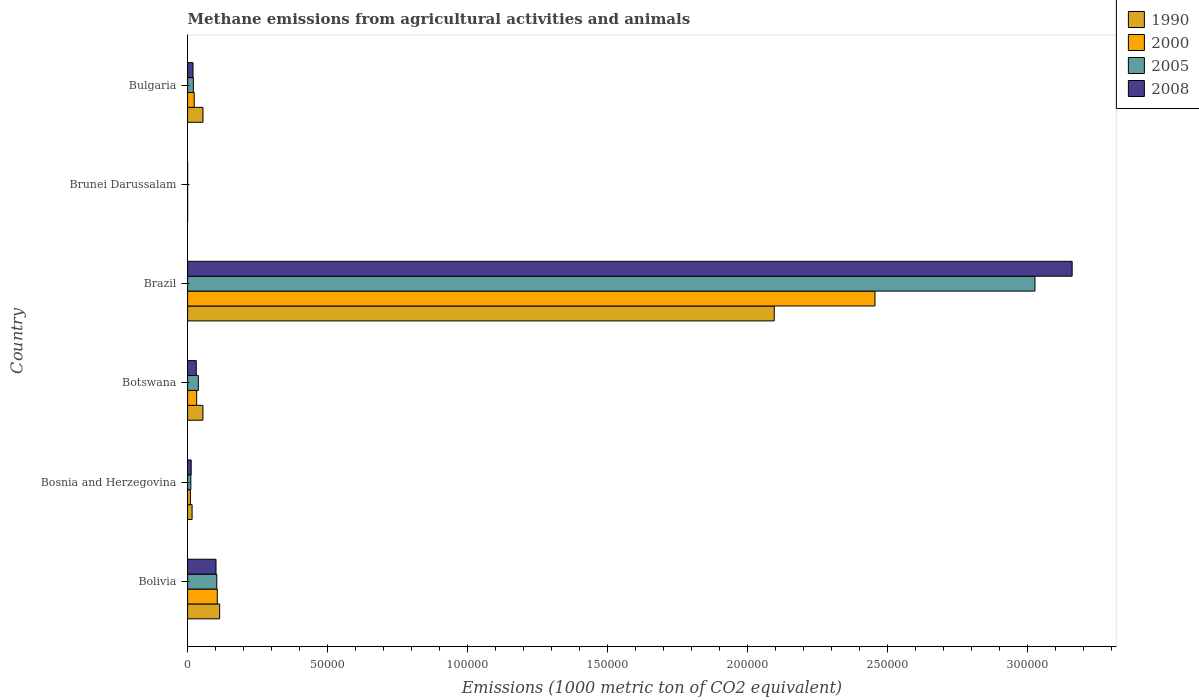How many groups of bars are there?
Your response must be concise. 6. How many bars are there on the 1st tick from the bottom?
Your response must be concise. 4. What is the amount of methane emitted in 2000 in Botswana?
Make the answer very short. 3234. Across all countries, what is the maximum amount of methane emitted in 1990?
Provide a succinct answer. 2.10e+05. In which country was the amount of methane emitted in 2000 minimum?
Your answer should be very brief. Brunei Darussalam. What is the total amount of methane emitted in 2008 in the graph?
Make the answer very short. 3.32e+05. What is the difference between the amount of methane emitted in 2008 in Botswana and that in Brazil?
Provide a short and direct response. -3.13e+05. What is the difference between the amount of methane emitted in 2008 in Botswana and the amount of methane emitted in 2000 in Brunei Darussalam?
Give a very brief answer. 3081.1. What is the average amount of methane emitted in 2005 per country?
Your response must be concise. 5.34e+04. What is the difference between the amount of methane emitted in 1990 and amount of methane emitted in 2005 in Brazil?
Provide a succinct answer. -9.31e+04. What is the ratio of the amount of methane emitted in 2008 in Botswana to that in Brunei Darussalam?
Provide a succinct answer. 216.53. Is the amount of methane emitted in 2008 in Brazil less than that in Brunei Darussalam?
Keep it short and to the point. No. What is the difference between the highest and the second highest amount of methane emitted in 1990?
Offer a very short reply. 1.98e+05. What is the difference between the highest and the lowest amount of methane emitted in 1990?
Provide a succinct answer. 2.10e+05. What does the 2nd bar from the top in Brunei Darussalam represents?
Keep it short and to the point. 2005. What is the difference between two consecutive major ticks on the X-axis?
Provide a succinct answer. 5.00e+04. Does the graph contain grids?
Offer a terse response. No. Where does the legend appear in the graph?
Your answer should be very brief. Top right. What is the title of the graph?
Provide a short and direct response. Methane emissions from agricultural activities and animals. What is the label or title of the X-axis?
Keep it short and to the point. Emissions (1000 metric ton of CO2 equivalent). What is the Emissions (1000 metric ton of CO2 equivalent) of 1990 in Bolivia?
Keep it short and to the point. 1.14e+04. What is the Emissions (1000 metric ton of CO2 equivalent) of 2000 in Bolivia?
Provide a short and direct response. 1.06e+04. What is the Emissions (1000 metric ton of CO2 equivalent) of 2005 in Bolivia?
Ensure brevity in your answer.  1.04e+04. What is the Emissions (1000 metric ton of CO2 equivalent) in 2008 in Bolivia?
Offer a terse response. 1.01e+04. What is the Emissions (1000 metric ton of CO2 equivalent) of 1990 in Bosnia and Herzegovina?
Offer a terse response. 1604.3. What is the Emissions (1000 metric ton of CO2 equivalent) in 2000 in Bosnia and Herzegovina?
Your response must be concise. 996.6. What is the Emissions (1000 metric ton of CO2 equivalent) in 2005 in Bosnia and Herzegovina?
Provide a succinct answer. 1161.2. What is the Emissions (1000 metric ton of CO2 equivalent) of 2008 in Bosnia and Herzegovina?
Make the answer very short. 1279.4. What is the Emissions (1000 metric ton of CO2 equivalent) of 1990 in Botswana?
Your response must be concise. 5471.2. What is the Emissions (1000 metric ton of CO2 equivalent) in 2000 in Botswana?
Your response must be concise. 3234. What is the Emissions (1000 metric ton of CO2 equivalent) in 2005 in Botswana?
Give a very brief answer. 3850.6. What is the Emissions (1000 metric ton of CO2 equivalent) of 2008 in Botswana?
Provide a succinct answer. 3096.4. What is the Emissions (1000 metric ton of CO2 equivalent) of 1990 in Brazil?
Give a very brief answer. 2.10e+05. What is the Emissions (1000 metric ton of CO2 equivalent) in 2000 in Brazil?
Give a very brief answer. 2.45e+05. What is the Emissions (1000 metric ton of CO2 equivalent) in 2005 in Brazil?
Offer a terse response. 3.03e+05. What is the Emissions (1000 metric ton of CO2 equivalent) of 2008 in Brazil?
Offer a very short reply. 3.16e+05. What is the Emissions (1000 metric ton of CO2 equivalent) in 2005 in Brunei Darussalam?
Give a very brief answer. 14.1. What is the Emissions (1000 metric ton of CO2 equivalent) in 1990 in Bulgaria?
Provide a succinct answer. 5498.3. What is the Emissions (1000 metric ton of CO2 equivalent) of 2000 in Bulgaria?
Offer a terse response. 2359.5. What is the Emissions (1000 metric ton of CO2 equivalent) in 2005 in Bulgaria?
Your answer should be compact. 2055.2. What is the Emissions (1000 metric ton of CO2 equivalent) of 2008 in Bulgaria?
Keep it short and to the point. 1942.2. Across all countries, what is the maximum Emissions (1000 metric ton of CO2 equivalent) of 1990?
Your answer should be very brief. 2.10e+05. Across all countries, what is the maximum Emissions (1000 metric ton of CO2 equivalent) in 2000?
Ensure brevity in your answer.  2.45e+05. Across all countries, what is the maximum Emissions (1000 metric ton of CO2 equivalent) in 2005?
Your answer should be compact. 3.03e+05. Across all countries, what is the maximum Emissions (1000 metric ton of CO2 equivalent) in 2008?
Ensure brevity in your answer.  3.16e+05. Across all countries, what is the minimum Emissions (1000 metric ton of CO2 equivalent) of 1990?
Keep it short and to the point. 12.5. Across all countries, what is the minimum Emissions (1000 metric ton of CO2 equivalent) in 2000?
Your answer should be very brief. 15.3. Across all countries, what is the minimum Emissions (1000 metric ton of CO2 equivalent) of 2008?
Your answer should be compact. 14.3. What is the total Emissions (1000 metric ton of CO2 equivalent) of 1990 in the graph?
Ensure brevity in your answer.  2.34e+05. What is the total Emissions (1000 metric ton of CO2 equivalent) in 2000 in the graph?
Give a very brief answer. 2.63e+05. What is the total Emissions (1000 metric ton of CO2 equivalent) of 2005 in the graph?
Make the answer very short. 3.20e+05. What is the total Emissions (1000 metric ton of CO2 equivalent) of 2008 in the graph?
Make the answer very short. 3.32e+05. What is the difference between the Emissions (1000 metric ton of CO2 equivalent) in 1990 in Bolivia and that in Bosnia and Herzegovina?
Offer a terse response. 9840.7. What is the difference between the Emissions (1000 metric ton of CO2 equivalent) in 2000 in Bolivia and that in Bosnia and Herzegovina?
Offer a very short reply. 9613.1. What is the difference between the Emissions (1000 metric ton of CO2 equivalent) in 2005 in Bolivia and that in Bosnia and Herzegovina?
Keep it short and to the point. 9254.6. What is the difference between the Emissions (1000 metric ton of CO2 equivalent) in 2008 in Bolivia and that in Bosnia and Herzegovina?
Provide a succinct answer. 8868.1. What is the difference between the Emissions (1000 metric ton of CO2 equivalent) of 1990 in Bolivia and that in Botswana?
Give a very brief answer. 5973.8. What is the difference between the Emissions (1000 metric ton of CO2 equivalent) of 2000 in Bolivia and that in Botswana?
Your answer should be compact. 7375.7. What is the difference between the Emissions (1000 metric ton of CO2 equivalent) in 2005 in Bolivia and that in Botswana?
Your answer should be compact. 6565.2. What is the difference between the Emissions (1000 metric ton of CO2 equivalent) in 2008 in Bolivia and that in Botswana?
Provide a succinct answer. 7051.1. What is the difference between the Emissions (1000 metric ton of CO2 equivalent) of 1990 in Bolivia and that in Brazil?
Keep it short and to the point. -1.98e+05. What is the difference between the Emissions (1000 metric ton of CO2 equivalent) of 2000 in Bolivia and that in Brazil?
Your response must be concise. -2.35e+05. What is the difference between the Emissions (1000 metric ton of CO2 equivalent) in 2005 in Bolivia and that in Brazil?
Offer a terse response. -2.92e+05. What is the difference between the Emissions (1000 metric ton of CO2 equivalent) in 2008 in Bolivia and that in Brazil?
Your response must be concise. -3.06e+05. What is the difference between the Emissions (1000 metric ton of CO2 equivalent) in 1990 in Bolivia and that in Brunei Darussalam?
Offer a very short reply. 1.14e+04. What is the difference between the Emissions (1000 metric ton of CO2 equivalent) of 2000 in Bolivia and that in Brunei Darussalam?
Ensure brevity in your answer.  1.06e+04. What is the difference between the Emissions (1000 metric ton of CO2 equivalent) in 2005 in Bolivia and that in Brunei Darussalam?
Offer a terse response. 1.04e+04. What is the difference between the Emissions (1000 metric ton of CO2 equivalent) in 2008 in Bolivia and that in Brunei Darussalam?
Keep it short and to the point. 1.01e+04. What is the difference between the Emissions (1000 metric ton of CO2 equivalent) of 1990 in Bolivia and that in Bulgaria?
Your answer should be compact. 5946.7. What is the difference between the Emissions (1000 metric ton of CO2 equivalent) of 2000 in Bolivia and that in Bulgaria?
Keep it short and to the point. 8250.2. What is the difference between the Emissions (1000 metric ton of CO2 equivalent) in 2005 in Bolivia and that in Bulgaria?
Ensure brevity in your answer.  8360.6. What is the difference between the Emissions (1000 metric ton of CO2 equivalent) of 2008 in Bolivia and that in Bulgaria?
Give a very brief answer. 8205.3. What is the difference between the Emissions (1000 metric ton of CO2 equivalent) in 1990 in Bosnia and Herzegovina and that in Botswana?
Offer a very short reply. -3866.9. What is the difference between the Emissions (1000 metric ton of CO2 equivalent) in 2000 in Bosnia and Herzegovina and that in Botswana?
Your answer should be very brief. -2237.4. What is the difference between the Emissions (1000 metric ton of CO2 equivalent) of 2005 in Bosnia and Herzegovina and that in Botswana?
Your answer should be very brief. -2689.4. What is the difference between the Emissions (1000 metric ton of CO2 equivalent) in 2008 in Bosnia and Herzegovina and that in Botswana?
Make the answer very short. -1817. What is the difference between the Emissions (1000 metric ton of CO2 equivalent) in 1990 in Bosnia and Herzegovina and that in Brazil?
Your answer should be compact. -2.08e+05. What is the difference between the Emissions (1000 metric ton of CO2 equivalent) in 2000 in Bosnia and Herzegovina and that in Brazil?
Your answer should be very brief. -2.44e+05. What is the difference between the Emissions (1000 metric ton of CO2 equivalent) in 2005 in Bosnia and Herzegovina and that in Brazil?
Make the answer very short. -3.01e+05. What is the difference between the Emissions (1000 metric ton of CO2 equivalent) in 2008 in Bosnia and Herzegovina and that in Brazil?
Offer a terse response. -3.15e+05. What is the difference between the Emissions (1000 metric ton of CO2 equivalent) in 1990 in Bosnia and Herzegovina and that in Brunei Darussalam?
Keep it short and to the point. 1591.8. What is the difference between the Emissions (1000 metric ton of CO2 equivalent) of 2000 in Bosnia and Herzegovina and that in Brunei Darussalam?
Provide a short and direct response. 981.3. What is the difference between the Emissions (1000 metric ton of CO2 equivalent) of 2005 in Bosnia and Herzegovina and that in Brunei Darussalam?
Ensure brevity in your answer.  1147.1. What is the difference between the Emissions (1000 metric ton of CO2 equivalent) in 2008 in Bosnia and Herzegovina and that in Brunei Darussalam?
Ensure brevity in your answer.  1265.1. What is the difference between the Emissions (1000 metric ton of CO2 equivalent) in 1990 in Bosnia and Herzegovina and that in Bulgaria?
Make the answer very short. -3894. What is the difference between the Emissions (1000 metric ton of CO2 equivalent) in 2000 in Bosnia and Herzegovina and that in Bulgaria?
Provide a short and direct response. -1362.9. What is the difference between the Emissions (1000 metric ton of CO2 equivalent) of 2005 in Bosnia and Herzegovina and that in Bulgaria?
Your answer should be compact. -894. What is the difference between the Emissions (1000 metric ton of CO2 equivalent) of 2008 in Bosnia and Herzegovina and that in Bulgaria?
Your response must be concise. -662.8. What is the difference between the Emissions (1000 metric ton of CO2 equivalent) in 1990 in Botswana and that in Brazil?
Provide a succinct answer. -2.04e+05. What is the difference between the Emissions (1000 metric ton of CO2 equivalent) of 2000 in Botswana and that in Brazil?
Your answer should be very brief. -2.42e+05. What is the difference between the Emissions (1000 metric ton of CO2 equivalent) of 2005 in Botswana and that in Brazil?
Give a very brief answer. -2.99e+05. What is the difference between the Emissions (1000 metric ton of CO2 equivalent) in 2008 in Botswana and that in Brazil?
Keep it short and to the point. -3.13e+05. What is the difference between the Emissions (1000 metric ton of CO2 equivalent) of 1990 in Botswana and that in Brunei Darussalam?
Ensure brevity in your answer.  5458.7. What is the difference between the Emissions (1000 metric ton of CO2 equivalent) of 2000 in Botswana and that in Brunei Darussalam?
Offer a terse response. 3218.7. What is the difference between the Emissions (1000 metric ton of CO2 equivalent) in 2005 in Botswana and that in Brunei Darussalam?
Make the answer very short. 3836.5. What is the difference between the Emissions (1000 metric ton of CO2 equivalent) of 2008 in Botswana and that in Brunei Darussalam?
Your answer should be very brief. 3082.1. What is the difference between the Emissions (1000 metric ton of CO2 equivalent) of 1990 in Botswana and that in Bulgaria?
Your answer should be very brief. -27.1. What is the difference between the Emissions (1000 metric ton of CO2 equivalent) of 2000 in Botswana and that in Bulgaria?
Your answer should be compact. 874.5. What is the difference between the Emissions (1000 metric ton of CO2 equivalent) in 2005 in Botswana and that in Bulgaria?
Make the answer very short. 1795.4. What is the difference between the Emissions (1000 metric ton of CO2 equivalent) in 2008 in Botswana and that in Bulgaria?
Ensure brevity in your answer.  1154.2. What is the difference between the Emissions (1000 metric ton of CO2 equivalent) of 1990 in Brazil and that in Brunei Darussalam?
Offer a very short reply. 2.10e+05. What is the difference between the Emissions (1000 metric ton of CO2 equivalent) in 2000 in Brazil and that in Brunei Darussalam?
Your answer should be compact. 2.45e+05. What is the difference between the Emissions (1000 metric ton of CO2 equivalent) of 2005 in Brazil and that in Brunei Darussalam?
Ensure brevity in your answer.  3.03e+05. What is the difference between the Emissions (1000 metric ton of CO2 equivalent) in 2008 in Brazil and that in Brunei Darussalam?
Your response must be concise. 3.16e+05. What is the difference between the Emissions (1000 metric ton of CO2 equivalent) of 1990 in Brazil and that in Bulgaria?
Provide a short and direct response. 2.04e+05. What is the difference between the Emissions (1000 metric ton of CO2 equivalent) in 2000 in Brazil and that in Bulgaria?
Provide a succinct answer. 2.43e+05. What is the difference between the Emissions (1000 metric ton of CO2 equivalent) in 2005 in Brazil and that in Bulgaria?
Keep it short and to the point. 3.01e+05. What is the difference between the Emissions (1000 metric ton of CO2 equivalent) of 2008 in Brazil and that in Bulgaria?
Your answer should be very brief. 3.14e+05. What is the difference between the Emissions (1000 metric ton of CO2 equivalent) in 1990 in Brunei Darussalam and that in Bulgaria?
Ensure brevity in your answer.  -5485.8. What is the difference between the Emissions (1000 metric ton of CO2 equivalent) of 2000 in Brunei Darussalam and that in Bulgaria?
Give a very brief answer. -2344.2. What is the difference between the Emissions (1000 metric ton of CO2 equivalent) in 2005 in Brunei Darussalam and that in Bulgaria?
Give a very brief answer. -2041.1. What is the difference between the Emissions (1000 metric ton of CO2 equivalent) of 2008 in Brunei Darussalam and that in Bulgaria?
Provide a short and direct response. -1927.9. What is the difference between the Emissions (1000 metric ton of CO2 equivalent) of 1990 in Bolivia and the Emissions (1000 metric ton of CO2 equivalent) of 2000 in Bosnia and Herzegovina?
Keep it short and to the point. 1.04e+04. What is the difference between the Emissions (1000 metric ton of CO2 equivalent) in 1990 in Bolivia and the Emissions (1000 metric ton of CO2 equivalent) in 2005 in Bosnia and Herzegovina?
Offer a very short reply. 1.03e+04. What is the difference between the Emissions (1000 metric ton of CO2 equivalent) of 1990 in Bolivia and the Emissions (1000 metric ton of CO2 equivalent) of 2008 in Bosnia and Herzegovina?
Ensure brevity in your answer.  1.02e+04. What is the difference between the Emissions (1000 metric ton of CO2 equivalent) in 2000 in Bolivia and the Emissions (1000 metric ton of CO2 equivalent) in 2005 in Bosnia and Herzegovina?
Ensure brevity in your answer.  9448.5. What is the difference between the Emissions (1000 metric ton of CO2 equivalent) of 2000 in Bolivia and the Emissions (1000 metric ton of CO2 equivalent) of 2008 in Bosnia and Herzegovina?
Offer a very short reply. 9330.3. What is the difference between the Emissions (1000 metric ton of CO2 equivalent) in 2005 in Bolivia and the Emissions (1000 metric ton of CO2 equivalent) in 2008 in Bosnia and Herzegovina?
Your answer should be compact. 9136.4. What is the difference between the Emissions (1000 metric ton of CO2 equivalent) of 1990 in Bolivia and the Emissions (1000 metric ton of CO2 equivalent) of 2000 in Botswana?
Provide a short and direct response. 8211. What is the difference between the Emissions (1000 metric ton of CO2 equivalent) in 1990 in Bolivia and the Emissions (1000 metric ton of CO2 equivalent) in 2005 in Botswana?
Give a very brief answer. 7594.4. What is the difference between the Emissions (1000 metric ton of CO2 equivalent) of 1990 in Bolivia and the Emissions (1000 metric ton of CO2 equivalent) of 2008 in Botswana?
Provide a succinct answer. 8348.6. What is the difference between the Emissions (1000 metric ton of CO2 equivalent) of 2000 in Bolivia and the Emissions (1000 metric ton of CO2 equivalent) of 2005 in Botswana?
Provide a short and direct response. 6759.1. What is the difference between the Emissions (1000 metric ton of CO2 equivalent) in 2000 in Bolivia and the Emissions (1000 metric ton of CO2 equivalent) in 2008 in Botswana?
Make the answer very short. 7513.3. What is the difference between the Emissions (1000 metric ton of CO2 equivalent) of 2005 in Bolivia and the Emissions (1000 metric ton of CO2 equivalent) of 2008 in Botswana?
Your answer should be very brief. 7319.4. What is the difference between the Emissions (1000 metric ton of CO2 equivalent) of 1990 in Bolivia and the Emissions (1000 metric ton of CO2 equivalent) of 2000 in Brazil?
Your answer should be compact. -2.34e+05. What is the difference between the Emissions (1000 metric ton of CO2 equivalent) in 1990 in Bolivia and the Emissions (1000 metric ton of CO2 equivalent) in 2005 in Brazil?
Offer a very short reply. -2.91e+05. What is the difference between the Emissions (1000 metric ton of CO2 equivalent) in 1990 in Bolivia and the Emissions (1000 metric ton of CO2 equivalent) in 2008 in Brazil?
Your response must be concise. -3.04e+05. What is the difference between the Emissions (1000 metric ton of CO2 equivalent) of 2000 in Bolivia and the Emissions (1000 metric ton of CO2 equivalent) of 2005 in Brazil?
Offer a terse response. -2.92e+05. What is the difference between the Emissions (1000 metric ton of CO2 equivalent) in 2000 in Bolivia and the Emissions (1000 metric ton of CO2 equivalent) in 2008 in Brazil?
Your answer should be compact. -3.05e+05. What is the difference between the Emissions (1000 metric ton of CO2 equivalent) in 2005 in Bolivia and the Emissions (1000 metric ton of CO2 equivalent) in 2008 in Brazil?
Give a very brief answer. -3.05e+05. What is the difference between the Emissions (1000 metric ton of CO2 equivalent) in 1990 in Bolivia and the Emissions (1000 metric ton of CO2 equivalent) in 2000 in Brunei Darussalam?
Give a very brief answer. 1.14e+04. What is the difference between the Emissions (1000 metric ton of CO2 equivalent) in 1990 in Bolivia and the Emissions (1000 metric ton of CO2 equivalent) in 2005 in Brunei Darussalam?
Make the answer very short. 1.14e+04. What is the difference between the Emissions (1000 metric ton of CO2 equivalent) of 1990 in Bolivia and the Emissions (1000 metric ton of CO2 equivalent) of 2008 in Brunei Darussalam?
Your answer should be compact. 1.14e+04. What is the difference between the Emissions (1000 metric ton of CO2 equivalent) of 2000 in Bolivia and the Emissions (1000 metric ton of CO2 equivalent) of 2005 in Brunei Darussalam?
Provide a succinct answer. 1.06e+04. What is the difference between the Emissions (1000 metric ton of CO2 equivalent) in 2000 in Bolivia and the Emissions (1000 metric ton of CO2 equivalent) in 2008 in Brunei Darussalam?
Your answer should be compact. 1.06e+04. What is the difference between the Emissions (1000 metric ton of CO2 equivalent) in 2005 in Bolivia and the Emissions (1000 metric ton of CO2 equivalent) in 2008 in Brunei Darussalam?
Offer a terse response. 1.04e+04. What is the difference between the Emissions (1000 metric ton of CO2 equivalent) of 1990 in Bolivia and the Emissions (1000 metric ton of CO2 equivalent) of 2000 in Bulgaria?
Offer a terse response. 9085.5. What is the difference between the Emissions (1000 metric ton of CO2 equivalent) in 1990 in Bolivia and the Emissions (1000 metric ton of CO2 equivalent) in 2005 in Bulgaria?
Offer a terse response. 9389.8. What is the difference between the Emissions (1000 metric ton of CO2 equivalent) in 1990 in Bolivia and the Emissions (1000 metric ton of CO2 equivalent) in 2008 in Bulgaria?
Keep it short and to the point. 9502.8. What is the difference between the Emissions (1000 metric ton of CO2 equivalent) of 2000 in Bolivia and the Emissions (1000 metric ton of CO2 equivalent) of 2005 in Bulgaria?
Ensure brevity in your answer.  8554.5. What is the difference between the Emissions (1000 metric ton of CO2 equivalent) in 2000 in Bolivia and the Emissions (1000 metric ton of CO2 equivalent) in 2008 in Bulgaria?
Provide a short and direct response. 8667.5. What is the difference between the Emissions (1000 metric ton of CO2 equivalent) in 2005 in Bolivia and the Emissions (1000 metric ton of CO2 equivalent) in 2008 in Bulgaria?
Make the answer very short. 8473.6. What is the difference between the Emissions (1000 metric ton of CO2 equivalent) of 1990 in Bosnia and Herzegovina and the Emissions (1000 metric ton of CO2 equivalent) of 2000 in Botswana?
Provide a succinct answer. -1629.7. What is the difference between the Emissions (1000 metric ton of CO2 equivalent) in 1990 in Bosnia and Herzegovina and the Emissions (1000 metric ton of CO2 equivalent) in 2005 in Botswana?
Make the answer very short. -2246.3. What is the difference between the Emissions (1000 metric ton of CO2 equivalent) of 1990 in Bosnia and Herzegovina and the Emissions (1000 metric ton of CO2 equivalent) of 2008 in Botswana?
Your response must be concise. -1492.1. What is the difference between the Emissions (1000 metric ton of CO2 equivalent) of 2000 in Bosnia and Herzegovina and the Emissions (1000 metric ton of CO2 equivalent) of 2005 in Botswana?
Offer a very short reply. -2854. What is the difference between the Emissions (1000 metric ton of CO2 equivalent) in 2000 in Bosnia and Herzegovina and the Emissions (1000 metric ton of CO2 equivalent) in 2008 in Botswana?
Your answer should be very brief. -2099.8. What is the difference between the Emissions (1000 metric ton of CO2 equivalent) in 2005 in Bosnia and Herzegovina and the Emissions (1000 metric ton of CO2 equivalent) in 2008 in Botswana?
Your response must be concise. -1935.2. What is the difference between the Emissions (1000 metric ton of CO2 equivalent) of 1990 in Bosnia and Herzegovina and the Emissions (1000 metric ton of CO2 equivalent) of 2000 in Brazil?
Ensure brevity in your answer.  -2.44e+05. What is the difference between the Emissions (1000 metric ton of CO2 equivalent) in 1990 in Bosnia and Herzegovina and the Emissions (1000 metric ton of CO2 equivalent) in 2005 in Brazil?
Keep it short and to the point. -3.01e+05. What is the difference between the Emissions (1000 metric ton of CO2 equivalent) in 1990 in Bosnia and Herzegovina and the Emissions (1000 metric ton of CO2 equivalent) in 2008 in Brazil?
Provide a short and direct response. -3.14e+05. What is the difference between the Emissions (1000 metric ton of CO2 equivalent) of 2000 in Bosnia and Herzegovina and the Emissions (1000 metric ton of CO2 equivalent) of 2005 in Brazil?
Offer a very short reply. -3.02e+05. What is the difference between the Emissions (1000 metric ton of CO2 equivalent) in 2000 in Bosnia and Herzegovina and the Emissions (1000 metric ton of CO2 equivalent) in 2008 in Brazil?
Keep it short and to the point. -3.15e+05. What is the difference between the Emissions (1000 metric ton of CO2 equivalent) in 2005 in Bosnia and Herzegovina and the Emissions (1000 metric ton of CO2 equivalent) in 2008 in Brazil?
Your answer should be very brief. -3.15e+05. What is the difference between the Emissions (1000 metric ton of CO2 equivalent) of 1990 in Bosnia and Herzegovina and the Emissions (1000 metric ton of CO2 equivalent) of 2000 in Brunei Darussalam?
Provide a short and direct response. 1589. What is the difference between the Emissions (1000 metric ton of CO2 equivalent) of 1990 in Bosnia and Herzegovina and the Emissions (1000 metric ton of CO2 equivalent) of 2005 in Brunei Darussalam?
Keep it short and to the point. 1590.2. What is the difference between the Emissions (1000 metric ton of CO2 equivalent) of 1990 in Bosnia and Herzegovina and the Emissions (1000 metric ton of CO2 equivalent) of 2008 in Brunei Darussalam?
Your answer should be very brief. 1590. What is the difference between the Emissions (1000 metric ton of CO2 equivalent) of 2000 in Bosnia and Herzegovina and the Emissions (1000 metric ton of CO2 equivalent) of 2005 in Brunei Darussalam?
Provide a short and direct response. 982.5. What is the difference between the Emissions (1000 metric ton of CO2 equivalent) of 2000 in Bosnia and Herzegovina and the Emissions (1000 metric ton of CO2 equivalent) of 2008 in Brunei Darussalam?
Your response must be concise. 982.3. What is the difference between the Emissions (1000 metric ton of CO2 equivalent) in 2005 in Bosnia and Herzegovina and the Emissions (1000 metric ton of CO2 equivalent) in 2008 in Brunei Darussalam?
Ensure brevity in your answer.  1146.9. What is the difference between the Emissions (1000 metric ton of CO2 equivalent) in 1990 in Bosnia and Herzegovina and the Emissions (1000 metric ton of CO2 equivalent) in 2000 in Bulgaria?
Provide a succinct answer. -755.2. What is the difference between the Emissions (1000 metric ton of CO2 equivalent) of 1990 in Bosnia and Herzegovina and the Emissions (1000 metric ton of CO2 equivalent) of 2005 in Bulgaria?
Your answer should be compact. -450.9. What is the difference between the Emissions (1000 metric ton of CO2 equivalent) in 1990 in Bosnia and Herzegovina and the Emissions (1000 metric ton of CO2 equivalent) in 2008 in Bulgaria?
Provide a short and direct response. -337.9. What is the difference between the Emissions (1000 metric ton of CO2 equivalent) in 2000 in Bosnia and Herzegovina and the Emissions (1000 metric ton of CO2 equivalent) in 2005 in Bulgaria?
Your answer should be very brief. -1058.6. What is the difference between the Emissions (1000 metric ton of CO2 equivalent) of 2000 in Bosnia and Herzegovina and the Emissions (1000 metric ton of CO2 equivalent) of 2008 in Bulgaria?
Ensure brevity in your answer.  -945.6. What is the difference between the Emissions (1000 metric ton of CO2 equivalent) of 2005 in Bosnia and Herzegovina and the Emissions (1000 metric ton of CO2 equivalent) of 2008 in Bulgaria?
Offer a very short reply. -781. What is the difference between the Emissions (1000 metric ton of CO2 equivalent) of 1990 in Botswana and the Emissions (1000 metric ton of CO2 equivalent) of 2000 in Brazil?
Make the answer very short. -2.40e+05. What is the difference between the Emissions (1000 metric ton of CO2 equivalent) in 1990 in Botswana and the Emissions (1000 metric ton of CO2 equivalent) in 2005 in Brazil?
Your answer should be very brief. -2.97e+05. What is the difference between the Emissions (1000 metric ton of CO2 equivalent) in 1990 in Botswana and the Emissions (1000 metric ton of CO2 equivalent) in 2008 in Brazil?
Offer a very short reply. -3.10e+05. What is the difference between the Emissions (1000 metric ton of CO2 equivalent) in 2000 in Botswana and the Emissions (1000 metric ton of CO2 equivalent) in 2005 in Brazil?
Your answer should be very brief. -2.99e+05. What is the difference between the Emissions (1000 metric ton of CO2 equivalent) in 2000 in Botswana and the Emissions (1000 metric ton of CO2 equivalent) in 2008 in Brazil?
Your response must be concise. -3.13e+05. What is the difference between the Emissions (1000 metric ton of CO2 equivalent) in 2005 in Botswana and the Emissions (1000 metric ton of CO2 equivalent) in 2008 in Brazil?
Offer a very short reply. -3.12e+05. What is the difference between the Emissions (1000 metric ton of CO2 equivalent) of 1990 in Botswana and the Emissions (1000 metric ton of CO2 equivalent) of 2000 in Brunei Darussalam?
Ensure brevity in your answer.  5455.9. What is the difference between the Emissions (1000 metric ton of CO2 equivalent) of 1990 in Botswana and the Emissions (1000 metric ton of CO2 equivalent) of 2005 in Brunei Darussalam?
Provide a succinct answer. 5457.1. What is the difference between the Emissions (1000 metric ton of CO2 equivalent) of 1990 in Botswana and the Emissions (1000 metric ton of CO2 equivalent) of 2008 in Brunei Darussalam?
Your answer should be very brief. 5456.9. What is the difference between the Emissions (1000 metric ton of CO2 equivalent) of 2000 in Botswana and the Emissions (1000 metric ton of CO2 equivalent) of 2005 in Brunei Darussalam?
Give a very brief answer. 3219.9. What is the difference between the Emissions (1000 metric ton of CO2 equivalent) in 2000 in Botswana and the Emissions (1000 metric ton of CO2 equivalent) in 2008 in Brunei Darussalam?
Provide a short and direct response. 3219.7. What is the difference between the Emissions (1000 metric ton of CO2 equivalent) in 2005 in Botswana and the Emissions (1000 metric ton of CO2 equivalent) in 2008 in Brunei Darussalam?
Offer a terse response. 3836.3. What is the difference between the Emissions (1000 metric ton of CO2 equivalent) of 1990 in Botswana and the Emissions (1000 metric ton of CO2 equivalent) of 2000 in Bulgaria?
Your answer should be compact. 3111.7. What is the difference between the Emissions (1000 metric ton of CO2 equivalent) in 1990 in Botswana and the Emissions (1000 metric ton of CO2 equivalent) in 2005 in Bulgaria?
Your answer should be very brief. 3416. What is the difference between the Emissions (1000 metric ton of CO2 equivalent) of 1990 in Botswana and the Emissions (1000 metric ton of CO2 equivalent) of 2008 in Bulgaria?
Offer a terse response. 3529. What is the difference between the Emissions (1000 metric ton of CO2 equivalent) in 2000 in Botswana and the Emissions (1000 metric ton of CO2 equivalent) in 2005 in Bulgaria?
Keep it short and to the point. 1178.8. What is the difference between the Emissions (1000 metric ton of CO2 equivalent) in 2000 in Botswana and the Emissions (1000 metric ton of CO2 equivalent) in 2008 in Bulgaria?
Make the answer very short. 1291.8. What is the difference between the Emissions (1000 metric ton of CO2 equivalent) of 2005 in Botswana and the Emissions (1000 metric ton of CO2 equivalent) of 2008 in Bulgaria?
Provide a succinct answer. 1908.4. What is the difference between the Emissions (1000 metric ton of CO2 equivalent) in 1990 in Brazil and the Emissions (1000 metric ton of CO2 equivalent) in 2000 in Brunei Darussalam?
Provide a succinct answer. 2.10e+05. What is the difference between the Emissions (1000 metric ton of CO2 equivalent) in 1990 in Brazil and the Emissions (1000 metric ton of CO2 equivalent) in 2005 in Brunei Darussalam?
Your answer should be compact. 2.10e+05. What is the difference between the Emissions (1000 metric ton of CO2 equivalent) in 1990 in Brazil and the Emissions (1000 metric ton of CO2 equivalent) in 2008 in Brunei Darussalam?
Make the answer very short. 2.10e+05. What is the difference between the Emissions (1000 metric ton of CO2 equivalent) of 2000 in Brazil and the Emissions (1000 metric ton of CO2 equivalent) of 2005 in Brunei Darussalam?
Your response must be concise. 2.45e+05. What is the difference between the Emissions (1000 metric ton of CO2 equivalent) in 2000 in Brazil and the Emissions (1000 metric ton of CO2 equivalent) in 2008 in Brunei Darussalam?
Offer a terse response. 2.45e+05. What is the difference between the Emissions (1000 metric ton of CO2 equivalent) in 2005 in Brazil and the Emissions (1000 metric ton of CO2 equivalent) in 2008 in Brunei Darussalam?
Provide a succinct answer. 3.03e+05. What is the difference between the Emissions (1000 metric ton of CO2 equivalent) of 1990 in Brazil and the Emissions (1000 metric ton of CO2 equivalent) of 2000 in Bulgaria?
Offer a very short reply. 2.07e+05. What is the difference between the Emissions (1000 metric ton of CO2 equivalent) of 1990 in Brazil and the Emissions (1000 metric ton of CO2 equivalent) of 2005 in Bulgaria?
Offer a very short reply. 2.07e+05. What is the difference between the Emissions (1000 metric ton of CO2 equivalent) in 1990 in Brazil and the Emissions (1000 metric ton of CO2 equivalent) in 2008 in Bulgaria?
Your answer should be compact. 2.08e+05. What is the difference between the Emissions (1000 metric ton of CO2 equivalent) of 2000 in Brazil and the Emissions (1000 metric ton of CO2 equivalent) of 2005 in Bulgaria?
Offer a terse response. 2.43e+05. What is the difference between the Emissions (1000 metric ton of CO2 equivalent) in 2000 in Brazil and the Emissions (1000 metric ton of CO2 equivalent) in 2008 in Bulgaria?
Make the answer very short. 2.44e+05. What is the difference between the Emissions (1000 metric ton of CO2 equivalent) in 2005 in Brazil and the Emissions (1000 metric ton of CO2 equivalent) in 2008 in Bulgaria?
Provide a succinct answer. 3.01e+05. What is the difference between the Emissions (1000 metric ton of CO2 equivalent) of 1990 in Brunei Darussalam and the Emissions (1000 metric ton of CO2 equivalent) of 2000 in Bulgaria?
Provide a succinct answer. -2347. What is the difference between the Emissions (1000 metric ton of CO2 equivalent) of 1990 in Brunei Darussalam and the Emissions (1000 metric ton of CO2 equivalent) of 2005 in Bulgaria?
Your answer should be very brief. -2042.7. What is the difference between the Emissions (1000 metric ton of CO2 equivalent) of 1990 in Brunei Darussalam and the Emissions (1000 metric ton of CO2 equivalent) of 2008 in Bulgaria?
Your answer should be very brief. -1929.7. What is the difference between the Emissions (1000 metric ton of CO2 equivalent) of 2000 in Brunei Darussalam and the Emissions (1000 metric ton of CO2 equivalent) of 2005 in Bulgaria?
Your answer should be compact. -2039.9. What is the difference between the Emissions (1000 metric ton of CO2 equivalent) in 2000 in Brunei Darussalam and the Emissions (1000 metric ton of CO2 equivalent) in 2008 in Bulgaria?
Ensure brevity in your answer.  -1926.9. What is the difference between the Emissions (1000 metric ton of CO2 equivalent) of 2005 in Brunei Darussalam and the Emissions (1000 metric ton of CO2 equivalent) of 2008 in Bulgaria?
Offer a very short reply. -1928.1. What is the average Emissions (1000 metric ton of CO2 equivalent) of 1990 per country?
Your answer should be very brief. 3.89e+04. What is the average Emissions (1000 metric ton of CO2 equivalent) in 2000 per country?
Offer a very short reply. 4.38e+04. What is the average Emissions (1000 metric ton of CO2 equivalent) of 2005 per country?
Give a very brief answer. 5.34e+04. What is the average Emissions (1000 metric ton of CO2 equivalent) in 2008 per country?
Make the answer very short. 5.54e+04. What is the difference between the Emissions (1000 metric ton of CO2 equivalent) in 1990 and Emissions (1000 metric ton of CO2 equivalent) in 2000 in Bolivia?
Keep it short and to the point. 835.3. What is the difference between the Emissions (1000 metric ton of CO2 equivalent) in 1990 and Emissions (1000 metric ton of CO2 equivalent) in 2005 in Bolivia?
Offer a very short reply. 1029.2. What is the difference between the Emissions (1000 metric ton of CO2 equivalent) in 1990 and Emissions (1000 metric ton of CO2 equivalent) in 2008 in Bolivia?
Offer a very short reply. 1297.5. What is the difference between the Emissions (1000 metric ton of CO2 equivalent) in 2000 and Emissions (1000 metric ton of CO2 equivalent) in 2005 in Bolivia?
Provide a short and direct response. 193.9. What is the difference between the Emissions (1000 metric ton of CO2 equivalent) of 2000 and Emissions (1000 metric ton of CO2 equivalent) of 2008 in Bolivia?
Give a very brief answer. 462.2. What is the difference between the Emissions (1000 metric ton of CO2 equivalent) of 2005 and Emissions (1000 metric ton of CO2 equivalent) of 2008 in Bolivia?
Offer a very short reply. 268.3. What is the difference between the Emissions (1000 metric ton of CO2 equivalent) of 1990 and Emissions (1000 metric ton of CO2 equivalent) of 2000 in Bosnia and Herzegovina?
Your response must be concise. 607.7. What is the difference between the Emissions (1000 metric ton of CO2 equivalent) of 1990 and Emissions (1000 metric ton of CO2 equivalent) of 2005 in Bosnia and Herzegovina?
Ensure brevity in your answer.  443.1. What is the difference between the Emissions (1000 metric ton of CO2 equivalent) in 1990 and Emissions (1000 metric ton of CO2 equivalent) in 2008 in Bosnia and Herzegovina?
Provide a succinct answer. 324.9. What is the difference between the Emissions (1000 metric ton of CO2 equivalent) in 2000 and Emissions (1000 metric ton of CO2 equivalent) in 2005 in Bosnia and Herzegovina?
Provide a short and direct response. -164.6. What is the difference between the Emissions (1000 metric ton of CO2 equivalent) in 2000 and Emissions (1000 metric ton of CO2 equivalent) in 2008 in Bosnia and Herzegovina?
Ensure brevity in your answer.  -282.8. What is the difference between the Emissions (1000 metric ton of CO2 equivalent) of 2005 and Emissions (1000 metric ton of CO2 equivalent) of 2008 in Bosnia and Herzegovina?
Keep it short and to the point. -118.2. What is the difference between the Emissions (1000 metric ton of CO2 equivalent) in 1990 and Emissions (1000 metric ton of CO2 equivalent) in 2000 in Botswana?
Offer a terse response. 2237.2. What is the difference between the Emissions (1000 metric ton of CO2 equivalent) of 1990 and Emissions (1000 metric ton of CO2 equivalent) of 2005 in Botswana?
Ensure brevity in your answer.  1620.6. What is the difference between the Emissions (1000 metric ton of CO2 equivalent) in 1990 and Emissions (1000 metric ton of CO2 equivalent) in 2008 in Botswana?
Provide a succinct answer. 2374.8. What is the difference between the Emissions (1000 metric ton of CO2 equivalent) of 2000 and Emissions (1000 metric ton of CO2 equivalent) of 2005 in Botswana?
Offer a very short reply. -616.6. What is the difference between the Emissions (1000 metric ton of CO2 equivalent) in 2000 and Emissions (1000 metric ton of CO2 equivalent) in 2008 in Botswana?
Your answer should be compact. 137.6. What is the difference between the Emissions (1000 metric ton of CO2 equivalent) of 2005 and Emissions (1000 metric ton of CO2 equivalent) of 2008 in Botswana?
Offer a very short reply. 754.2. What is the difference between the Emissions (1000 metric ton of CO2 equivalent) of 1990 and Emissions (1000 metric ton of CO2 equivalent) of 2000 in Brazil?
Provide a succinct answer. -3.60e+04. What is the difference between the Emissions (1000 metric ton of CO2 equivalent) of 1990 and Emissions (1000 metric ton of CO2 equivalent) of 2005 in Brazil?
Keep it short and to the point. -9.31e+04. What is the difference between the Emissions (1000 metric ton of CO2 equivalent) of 1990 and Emissions (1000 metric ton of CO2 equivalent) of 2008 in Brazil?
Make the answer very short. -1.06e+05. What is the difference between the Emissions (1000 metric ton of CO2 equivalent) of 2000 and Emissions (1000 metric ton of CO2 equivalent) of 2005 in Brazil?
Make the answer very short. -5.71e+04. What is the difference between the Emissions (1000 metric ton of CO2 equivalent) in 2000 and Emissions (1000 metric ton of CO2 equivalent) in 2008 in Brazil?
Offer a very short reply. -7.04e+04. What is the difference between the Emissions (1000 metric ton of CO2 equivalent) in 2005 and Emissions (1000 metric ton of CO2 equivalent) in 2008 in Brazil?
Offer a very short reply. -1.33e+04. What is the difference between the Emissions (1000 metric ton of CO2 equivalent) of 1990 and Emissions (1000 metric ton of CO2 equivalent) of 2000 in Brunei Darussalam?
Make the answer very short. -2.8. What is the difference between the Emissions (1000 metric ton of CO2 equivalent) of 1990 and Emissions (1000 metric ton of CO2 equivalent) of 2005 in Brunei Darussalam?
Your answer should be very brief. -1.6. What is the difference between the Emissions (1000 metric ton of CO2 equivalent) of 1990 and Emissions (1000 metric ton of CO2 equivalent) of 2008 in Brunei Darussalam?
Your response must be concise. -1.8. What is the difference between the Emissions (1000 metric ton of CO2 equivalent) of 2000 and Emissions (1000 metric ton of CO2 equivalent) of 2005 in Brunei Darussalam?
Your response must be concise. 1.2. What is the difference between the Emissions (1000 metric ton of CO2 equivalent) in 1990 and Emissions (1000 metric ton of CO2 equivalent) in 2000 in Bulgaria?
Offer a very short reply. 3138.8. What is the difference between the Emissions (1000 metric ton of CO2 equivalent) in 1990 and Emissions (1000 metric ton of CO2 equivalent) in 2005 in Bulgaria?
Provide a short and direct response. 3443.1. What is the difference between the Emissions (1000 metric ton of CO2 equivalent) of 1990 and Emissions (1000 metric ton of CO2 equivalent) of 2008 in Bulgaria?
Provide a short and direct response. 3556.1. What is the difference between the Emissions (1000 metric ton of CO2 equivalent) in 2000 and Emissions (1000 metric ton of CO2 equivalent) in 2005 in Bulgaria?
Give a very brief answer. 304.3. What is the difference between the Emissions (1000 metric ton of CO2 equivalent) of 2000 and Emissions (1000 metric ton of CO2 equivalent) of 2008 in Bulgaria?
Your answer should be very brief. 417.3. What is the difference between the Emissions (1000 metric ton of CO2 equivalent) of 2005 and Emissions (1000 metric ton of CO2 equivalent) of 2008 in Bulgaria?
Give a very brief answer. 113. What is the ratio of the Emissions (1000 metric ton of CO2 equivalent) in 1990 in Bolivia to that in Bosnia and Herzegovina?
Ensure brevity in your answer.  7.13. What is the ratio of the Emissions (1000 metric ton of CO2 equivalent) of 2000 in Bolivia to that in Bosnia and Herzegovina?
Offer a terse response. 10.65. What is the ratio of the Emissions (1000 metric ton of CO2 equivalent) in 2005 in Bolivia to that in Bosnia and Herzegovina?
Give a very brief answer. 8.97. What is the ratio of the Emissions (1000 metric ton of CO2 equivalent) in 2008 in Bolivia to that in Bosnia and Herzegovina?
Offer a terse response. 7.93. What is the ratio of the Emissions (1000 metric ton of CO2 equivalent) in 1990 in Bolivia to that in Botswana?
Offer a very short reply. 2.09. What is the ratio of the Emissions (1000 metric ton of CO2 equivalent) in 2000 in Bolivia to that in Botswana?
Your response must be concise. 3.28. What is the ratio of the Emissions (1000 metric ton of CO2 equivalent) of 2005 in Bolivia to that in Botswana?
Make the answer very short. 2.71. What is the ratio of the Emissions (1000 metric ton of CO2 equivalent) of 2008 in Bolivia to that in Botswana?
Give a very brief answer. 3.28. What is the ratio of the Emissions (1000 metric ton of CO2 equivalent) of 1990 in Bolivia to that in Brazil?
Your answer should be compact. 0.05. What is the ratio of the Emissions (1000 metric ton of CO2 equivalent) of 2000 in Bolivia to that in Brazil?
Offer a terse response. 0.04. What is the ratio of the Emissions (1000 metric ton of CO2 equivalent) of 2005 in Bolivia to that in Brazil?
Provide a short and direct response. 0.03. What is the ratio of the Emissions (1000 metric ton of CO2 equivalent) in 2008 in Bolivia to that in Brazil?
Your response must be concise. 0.03. What is the ratio of the Emissions (1000 metric ton of CO2 equivalent) in 1990 in Bolivia to that in Brunei Darussalam?
Provide a short and direct response. 915.6. What is the ratio of the Emissions (1000 metric ton of CO2 equivalent) in 2000 in Bolivia to that in Brunei Darussalam?
Your response must be concise. 693.44. What is the ratio of the Emissions (1000 metric ton of CO2 equivalent) of 2005 in Bolivia to that in Brunei Darussalam?
Make the answer very short. 738.71. What is the ratio of the Emissions (1000 metric ton of CO2 equivalent) in 2008 in Bolivia to that in Brunei Darussalam?
Ensure brevity in your answer.  709.62. What is the ratio of the Emissions (1000 metric ton of CO2 equivalent) of 1990 in Bolivia to that in Bulgaria?
Your answer should be very brief. 2.08. What is the ratio of the Emissions (1000 metric ton of CO2 equivalent) of 2000 in Bolivia to that in Bulgaria?
Ensure brevity in your answer.  4.5. What is the ratio of the Emissions (1000 metric ton of CO2 equivalent) in 2005 in Bolivia to that in Bulgaria?
Offer a very short reply. 5.07. What is the ratio of the Emissions (1000 metric ton of CO2 equivalent) of 2008 in Bolivia to that in Bulgaria?
Offer a very short reply. 5.22. What is the ratio of the Emissions (1000 metric ton of CO2 equivalent) in 1990 in Bosnia and Herzegovina to that in Botswana?
Your response must be concise. 0.29. What is the ratio of the Emissions (1000 metric ton of CO2 equivalent) in 2000 in Bosnia and Herzegovina to that in Botswana?
Offer a terse response. 0.31. What is the ratio of the Emissions (1000 metric ton of CO2 equivalent) in 2005 in Bosnia and Herzegovina to that in Botswana?
Offer a terse response. 0.3. What is the ratio of the Emissions (1000 metric ton of CO2 equivalent) of 2008 in Bosnia and Herzegovina to that in Botswana?
Make the answer very short. 0.41. What is the ratio of the Emissions (1000 metric ton of CO2 equivalent) of 1990 in Bosnia and Herzegovina to that in Brazil?
Your answer should be very brief. 0.01. What is the ratio of the Emissions (1000 metric ton of CO2 equivalent) of 2000 in Bosnia and Herzegovina to that in Brazil?
Your response must be concise. 0. What is the ratio of the Emissions (1000 metric ton of CO2 equivalent) of 2005 in Bosnia and Herzegovina to that in Brazil?
Provide a short and direct response. 0. What is the ratio of the Emissions (1000 metric ton of CO2 equivalent) of 2008 in Bosnia and Herzegovina to that in Brazil?
Your answer should be very brief. 0. What is the ratio of the Emissions (1000 metric ton of CO2 equivalent) of 1990 in Bosnia and Herzegovina to that in Brunei Darussalam?
Make the answer very short. 128.34. What is the ratio of the Emissions (1000 metric ton of CO2 equivalent) in 2000 in Bosnia and Herzegovina to that in Brunei Darussalam?
Keep it short and to the point. 65.14. What is the ratio of the Emissions (1000 metric ton of CO2 equivalent) of 2005 in Bosnia and Herzegovina to that in Brunei Darussalam?
Offer a terse response. 82.35. What is the ratio of the Emissions (1000 metric ton of CO2 equivalent) in 2008 in Bosnia and Herzegovina to that in Brunei Darussalam?
Give a very brief answer. 89.47. What is the ratio of the Emissions (1000 metric ton of CO2 equivalent) in 1990 in Bosnia and Herzegovina to that in Bulgaria?
Make the answer very short. 0.29. What is the ratio of the Emissions (1000 metric ton of CO2 equivalent) of 2000 in Bosnia and Herzegovina to that in Bulgaria?
Provide a short and direct response. 0.42. What is the ratio of the Emissions (1000 metric ton of CO2 equivalent) in 2005 in Bosnia and Herzegovina to that in Bulgaria?
Keep it short and to the point. 0.56. What is the ratio of the Emissions (1000 metric ton of CO2 equivalent) in 2008 in Bosnia and Herzegovina to that in Bulgaria?
Make the answer very short. 0.66. What is the ratio of the Emissions (1000 metric ton of CO2 equivalent) of 1990 in Botswana to that in Brazil?
Provide a succinct answer. 0.03. What is the ratio of the Emissions (1000 metric ton of CO2 equivalent) in 2000 in Botswana to that in Brazil?
Provide a succinct answer. 0.01. What is the ratio of the Emissions (1000 metric ton of CO2 equivalent) in 2005 in Botswana to that in Brazil?
Provide a succinct answer. 0.01. What is the ratio of the Emissions (1000 metric ton of CO2 equivalent) in 2008 in Botswana to that in Brazil?
Offer a very short reply. 0.01. What is the ratio of the Emissions (1000 metric ton of CO2 equivalent) in 1990 in Botswana to that in Brunei Darussalam?
Ensure brevity in your answer.  437.7. What is the ratio of the Emissions (1000 metric ton of CO2 equivalent) of 2000 in Botswana to that in Brunei Darussalam?
Keep it short and to the point. 211.37. What is the ratio of the Emissions (1000 metric ton of CO2 equivalent) in 2005 in Botswana to that in Brunei Darussalam?
Make the answer very short. 273.09. What is the ratio of the Emissions (1000 metric ton of CO2 equivalent) in 2008 in Botswana to that in Brunei Darussalam?
Make the answer very short. 216.53. What is the ratio of the Emissions (1000 metric ton of CO2 equivalent) in 2000 in Botswana to that in Bulgaria?
Make the answer very short. 1.37. What is the ratio of the Emissions (1000 metric ton of CO2 equivalent) in 2005 in Botswana to that in Bulgaria?
Your response must be concise. 1.87. What is the ratio of the Emissions (1000 metric ton of CO2 equivalent) of 2008 in Botswana to that in Bulgaria?
Your answer should be very brief. 1.59. What is the ratio of the Emissions (1000 metric ton of CO2 equivalent) of 1990 in Brazil to that in Brunei Darussalam?
Your answer should be compact. 1.68e+04. What is the ratio of the Emissions (1000 metric ton of CO2 equivalent) in 2000 in Brazil to that in Brunei Darussalam?
Offer a terse response. 1.60e+04. What is the ratio of the Emissions (1000 metric ton of CO2 equivalent) in 2005 in Brazil to that in Brunei Darussalam?
Provide a short and direct response. 2.15e+04. What is the ratio of the Emissions (1000 metric ton of CO2 equivalent) in 2008 in Brazil to that in Brunei Darussalam?
Give a very brief answer. 2.21e+04. What is the ratio of the Emissions (1000 metric ton of CO2 equivalent) in 1990 in Brazil to that in Bulgaria?
Keep it short and to the point. 38.11. What is the ratio of the Emissions (1000 metric ton of CO2 equivalent) in 2000 in Brazil to that in Bulgaria?
Keep it short and to the point. 104.05. What is the ratio of the Emissions (1000 metric ton of CO2 equivalent) of 2005 in Brazil to that in Bulgaria?
Your response must be concise. 147.25. What is the ratio of the Emissions (1000 metric ton of CO2 equivalent) in 2008 in Brazil to that in Bulgaria?
Keep it short and to the point. 162.66. What is the ratio of the Emissions (1000 metric ton of CO2 equivalent) of 1990 in Brunei Darussalam to that in Bulgaria?
Offer a terse response. 0. What is the ratio of the Emissions (1000 metric ton of CO2 equivalent) in 2000 in Brunei Darussalam to that in Bulgaria?
Offer a terse response. 0.01. What is the ratio of the Emissions (1000 metric ton of CO2 equivalent) of 2005 in Brunei Darussalam to that in Bulgaria?
Your answer should be very brief. 0.01. What is the ratio of the Emissions (1000 metric ton of CO2 equivalent) in 2008 in Brunei Darussalam to that in Bulgaria?
Offer a terse response. 0.01. What is the difference between the highest and the second highest Emissions (1000 metric ton of CO2 equivalent) in 1990?
Offer a very short reply. 1.98e+05. What is the difference between the highest and the second highest Emissions (1000 metric ton of CO2 equivalent) of 2000?
Ensure brevity in your answer.  2.35e+05. What is the difference between the highest and the second highest Emissions (1000 metric ton of CO2 equivalent) in 2005?
Give a very brief answer. 2.92e+05. What is the difference between the highest and the second highest Emissions (1000 metric ton of CO2 equivalent) of 2008?
Keep it short and to the point. 3.06e+05. What is the difference between the highest and the lowest Emissions (1000 metric ton of CO2 equivalent) of 1990?
Ensure brevity in your answer.  2.10e+05. What is the difference between the highest and the lowest Emissions (1000 metric ton of CO2 equivalent) in 2000?
Give a very brief answer. 2.45e+05. What is the difference between the highest and the lowest Emissions (1000 metric ton of CO2 equivalent) in 2005?
Ensure brevity in your answer.  3.03e+05. What is the difference between the highest and the lowest Emissions (1000 metric ton of CO2 equivalent) in 2008?
Give a very brief answer. 3.16e+05. 